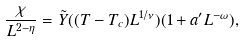Convert formula to latex. <formula><loc_0><loc_0><loc_500><loc_500>\frac { \chi } { L ^ { 2 - \eta } } = \tilde { Y } ( ( T - T _ { c } ) L ^ { 1 / \nu } ) ( 1 + a ^ { \prime } L ^ { - \omega } ) ,</formula> 